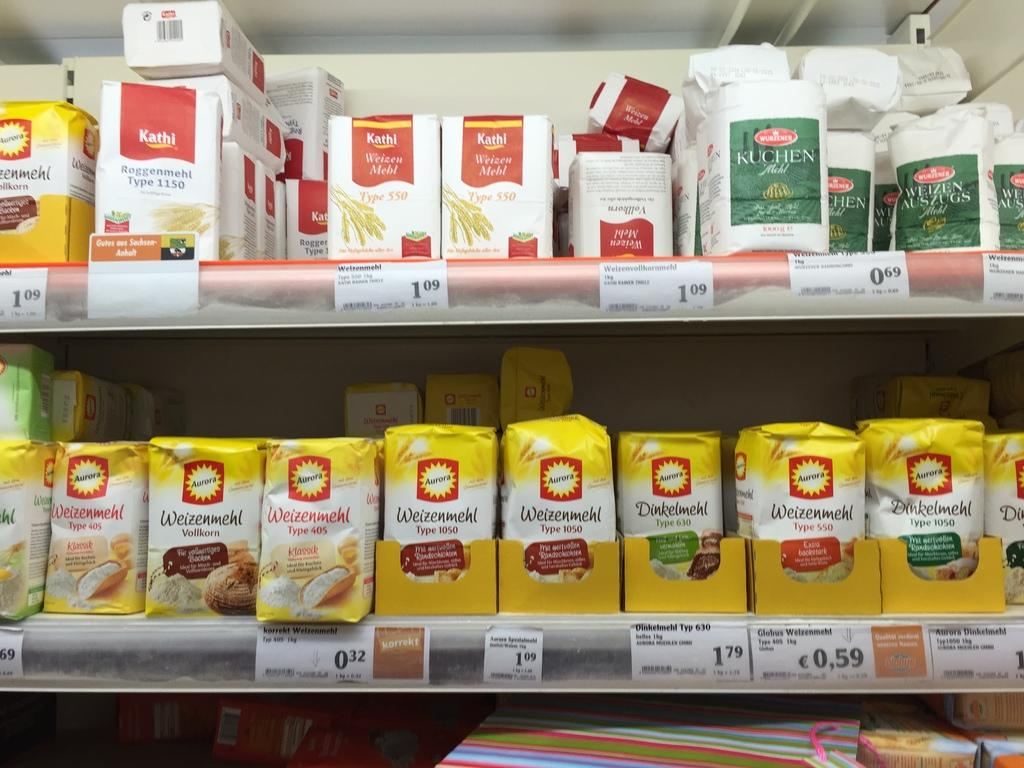What can be seen on the shelves in the image? There are objects on the shelves in the image. How can the prices of the objects be identified in the image? There are price tags on the shelves in the image. What type of ornament is bursting in the image? There is no ornament present in the image, nor is there any indication of something bursting. 